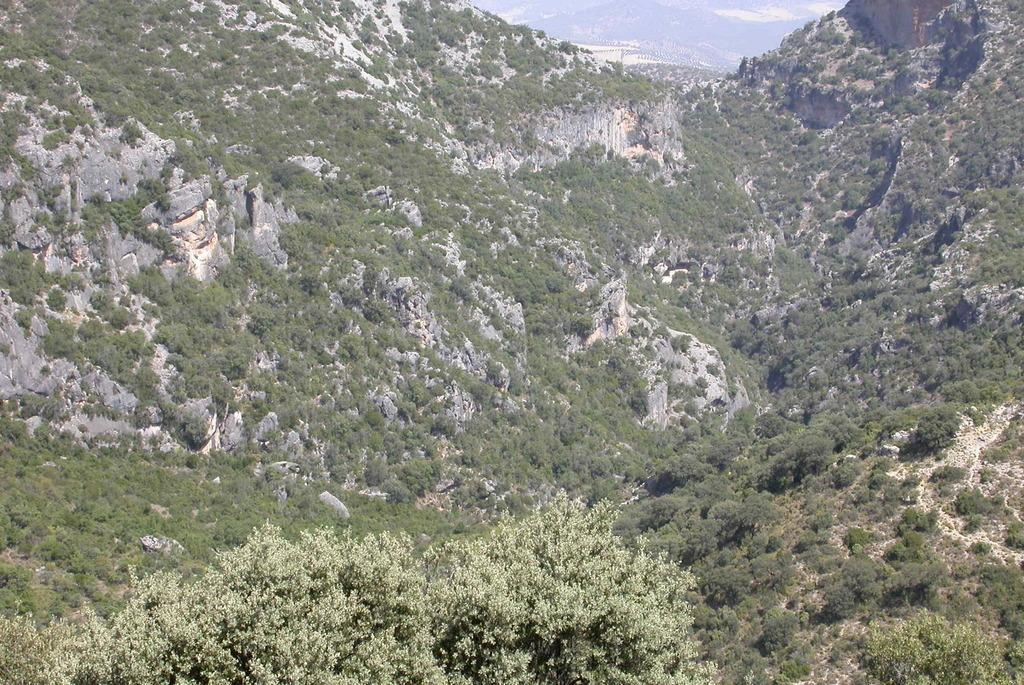What type of vegetation is present in the image? There are trees in the image. What is the color of the trees in the image? The trees are green. What type of geographical feature can be seen in the image? There are mountains in the image. What is the color of the mountains in the image? The mountains are green. What type of stew is being prepared in the image? There is no stew present in the image; it features trees and mountains. What mark can be seen on the trees in the image? There are no visible marks on the trees in the image. 